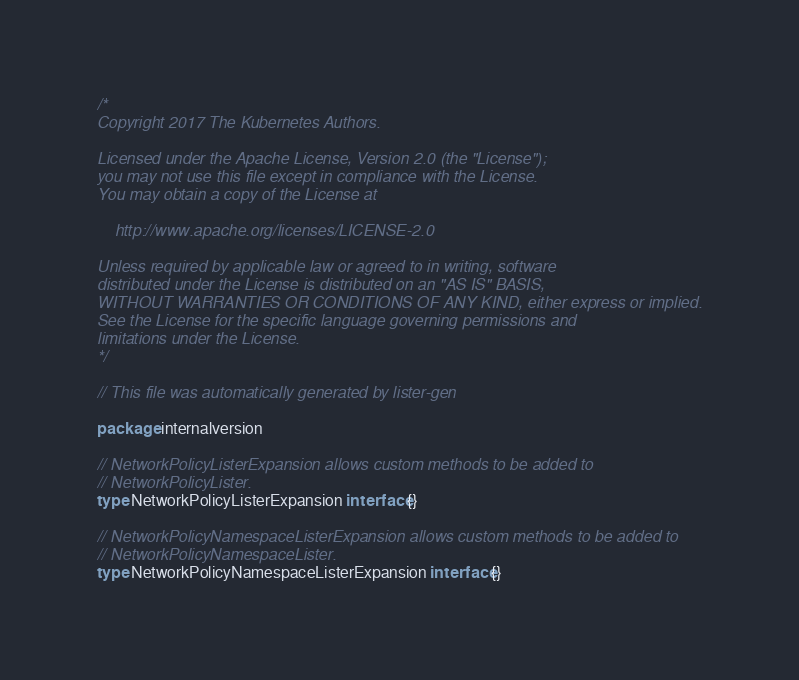<code> <loc_0><loc_0><loc_500><loc_500><_Go_>/*
Copyright 2017 The Kubernetes Authors.

Licensed under the Apache License, Version 2.0 (the "License");
you may not use this file except in compliance with the License.
You may obtain a copy of the License at

    http://www.apache.org/licenses/LICENSE-2.0

Unless required by applicable law or agreed to in writing, software
distributed under the License is distributed on an "AS IS" BASIS,
WITHOUT WARRANTIES OR CONDITIONS OF ANY KIND, either express or implied.
See the License for the specific language governing permissions and
limitations under the License.
*/

// This file was automatically generated by lister-gen

package internalversion

// NetworkPolicyListerExpansion allows custom methods to be added to
// NetworkPolicyLister.
type NetworkPolicyListerExpansion interface{}

// NetworkPolicyNamespaceListerExpansion allows custom methods to be added to
// NetworkPolicyNamespaceLister.
type NetworkPolicyNamespaceListerExpansion interface{}
</code> 